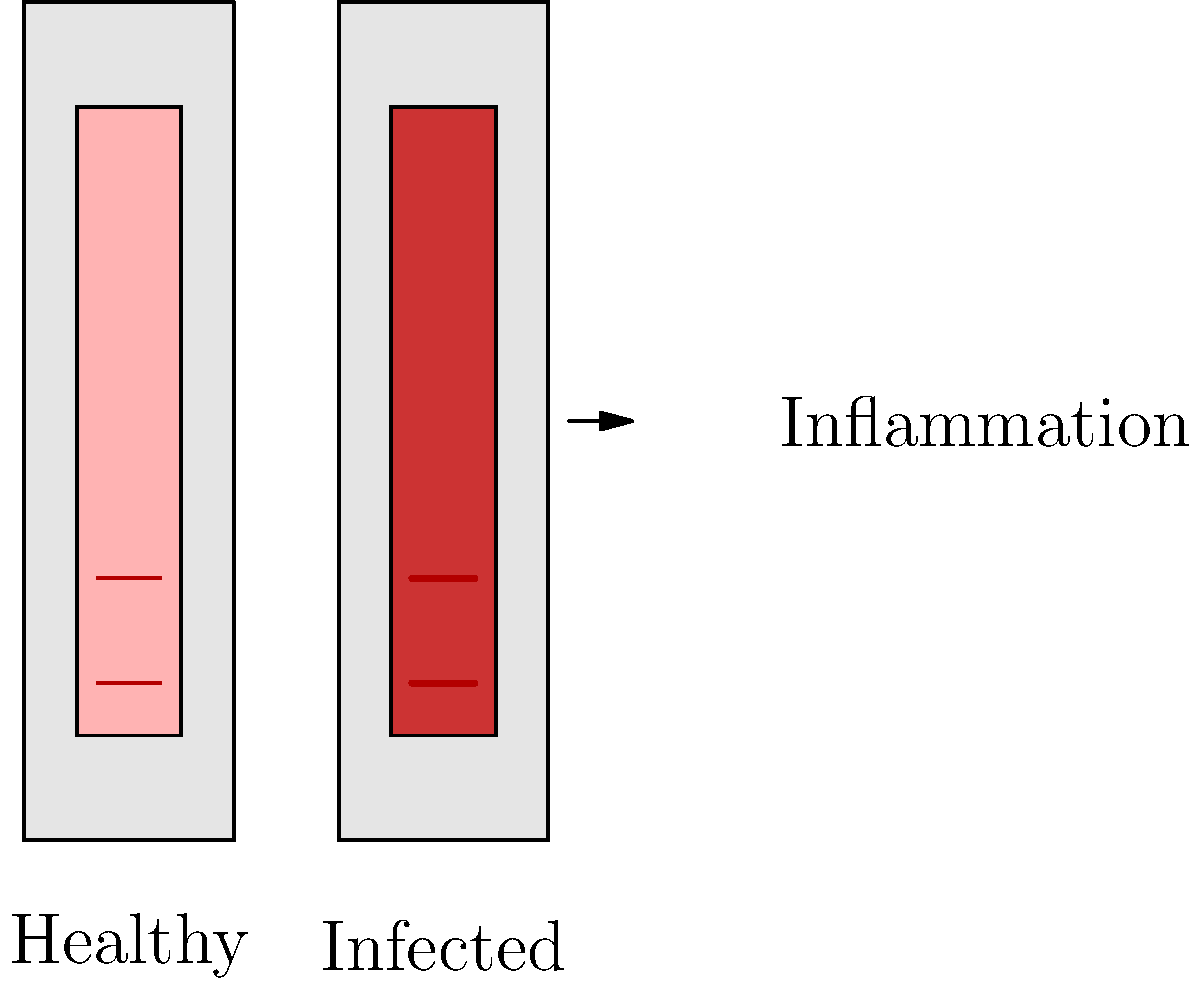Analyze the visual comparison of healthy vs. infected tooth pulp. Identify three key differences and explain how these changes impact the diagnosis and treatment approach in endodontic procedures. Step-by-step analysis of the key differences between healthy and infected tooth pulp:

1. Color change:
   - Healthy pulp: Light pink color, indicating normal blood flow and vitality.
   - Infected pulp: Dark red color, suggesting inflammation and increased blood flow.
   Impact: The color change is a critical diagnostic indicator. Darker pulp color often indicates the need for root canal treatment.

2. Blood vessel dilation:
   - Healthy pulp: Normal-sized blood vessels.
   - Infected pulp: Dilated blood vessels, appearing thicker and more prominent.
   Impact: Dilated blood vessels indicate increased blood flow due to inflammation, which may require more extensive cleaning and shaping during endodontic procedures.

3. Swelling of pulp tissue:
   - Healthy pulp: Normal pulp chamber size with defined borders.
   - Infected pulp: Slightly enlarged pulp chamber, indicating swelling of the pulp tissue.
   Impact: Swollen pulp tissue can lead to increased pressure within the tooth, causing pain and potentially requiring immediate intervention to relieve pressure and begin treatment.

These changes impact the diagnosis and treatment approach in endodontic procedures by:
a) Confirming the need for root canal treatment
b) Indicating the extent of infection and inflammation
c) Guiding the clinician in determining the appropriate cleaning and shaping techniques
d) Helping to estimate the complexity of the case and potential healing time
Answer: Color darkening, blood vessel dilation, pulp swelling 